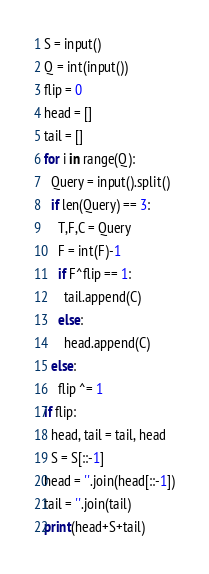<code> <loc_0><loc_0><loc_500><loc_500><_Cython_>S = input()
Q = int(input())
flip = 0
head = []
tail = []
for i in range(Q):
  Query = input().split()
  if len(Query) == 3:
    T,F,C = Query
    F = int(F)-1
    if F^flip == 1:
      tail.append(C)
    else:
      head.append(C)
  else:
    flip ^= 1
if flip:
  head, tail = tail, head
  S = S[::-1]
head = ''.join(head[::-1])
tail = ''.join(tail)
print(head+S+tail)
</code> 